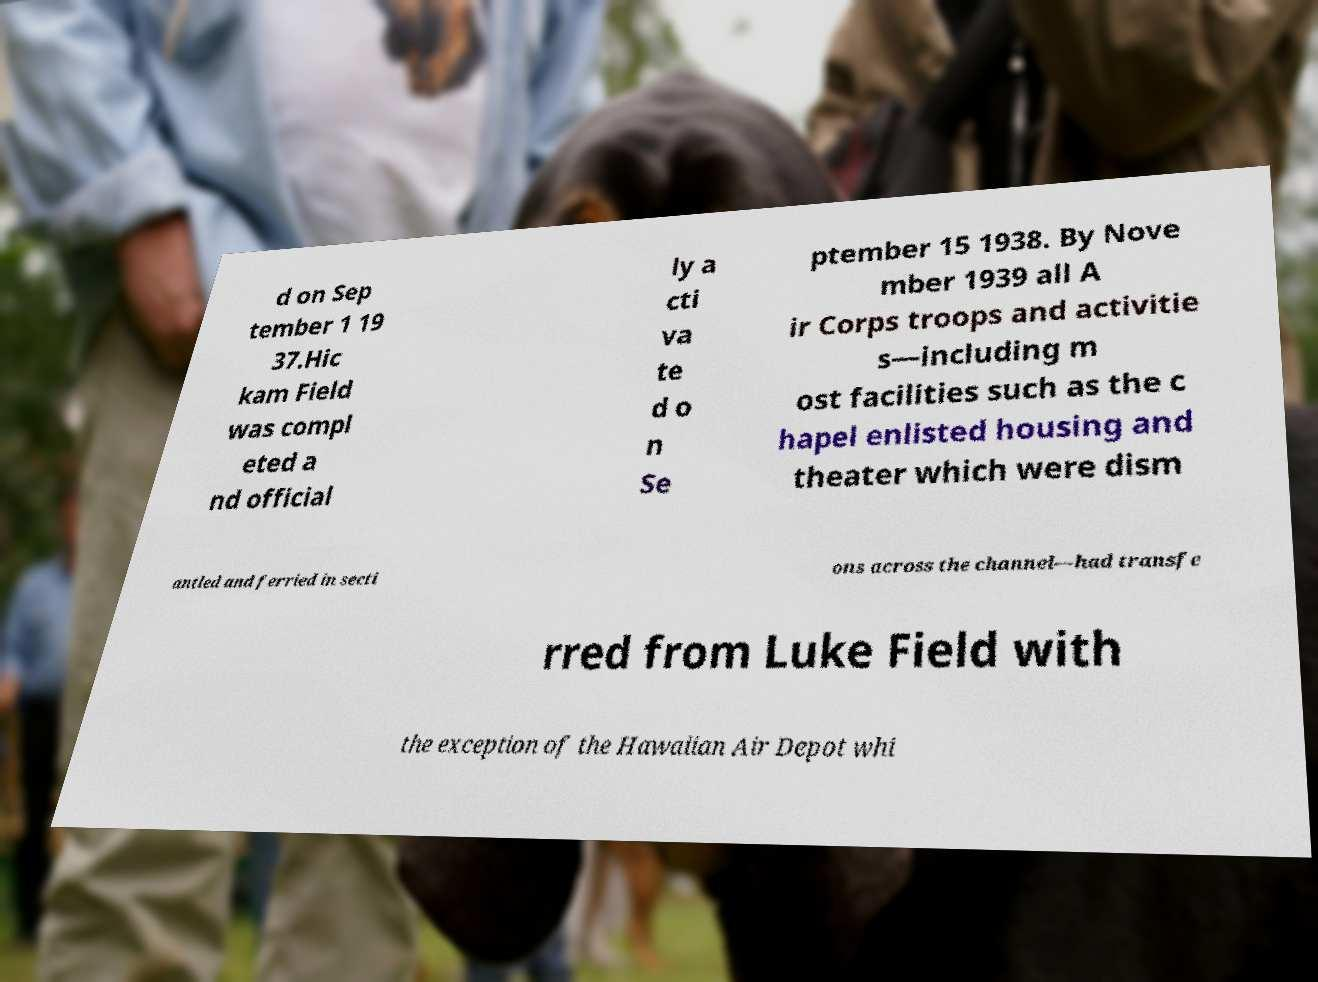Please read and relay the text visible in this image. What does it say? d on Sep tember 1 19 37.Hic kam Field was compl eted a nd official ly a cti va te d o n Se ptember 15 1938. By Nove mber 1939 all A ir Corps troops and activitie s—including m ost facilities such as the c hapel enlisted housing and theater which were dism antled and ferried in secti ons across the channel—had transfe rred from Luke Field with the exception of the Hawaiian Air Depot whi 